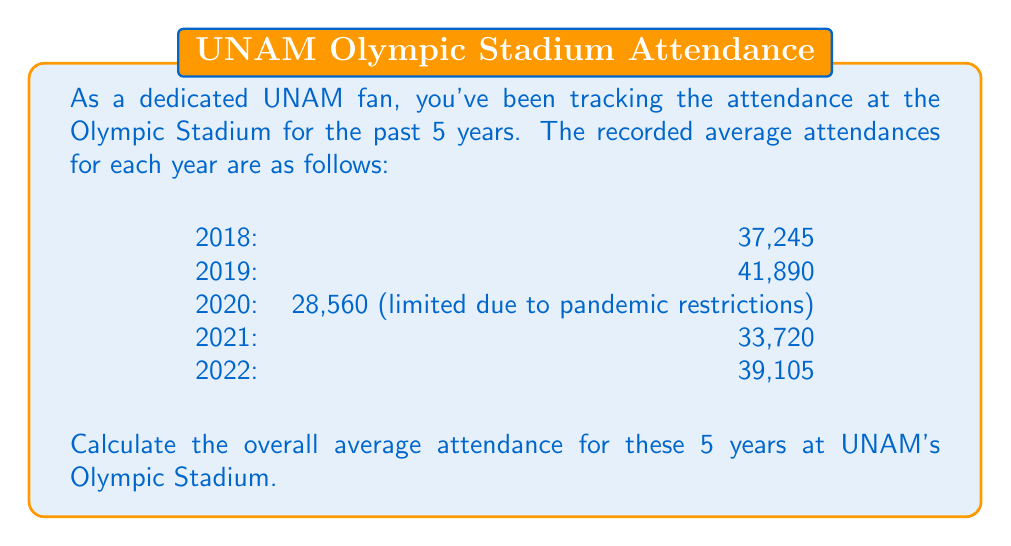Help me with this question. To find the overall average attendance, we need to:

1. Sum up the total attendance for all 5 years
2. Divide the sum by the number of years (5)

Let's break it down step-by-step:

1. Sum up the attendances:
   $$37,245 + 41,890 + 28,560 + 33,720 + 39,105 = 180,520$$

2. Divide by the number of years:
   $$\frac{180,520}{5} = 36,104$$

Therefore, the overall average attendance for these 5 years is 36,104 fans per year.

Note: It's important to recognize that 2020 had lower attendance due to pandemic restrictions, which affects the overall average. As a UNAM fan particular about historical facts, you might want to consider this context when interpreting the results.
Answer: The overall average attendance at UNAM's Olympic Stadium for the years 2018-2022 is 36,104 fans per year. 